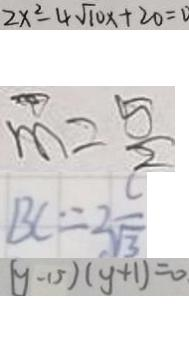Convert formula to latex. <formula><loc_0><loc_0><loc_500><loc_500>2 x ^ { 2 } - 4 \sqrt { 1 0 } x + 2 0 = 0 
 m = \frac { 5 } { 2 } 
 B C = 2 \frac { c } { \sqrt { 3 } } 
 ( y - 1 5 ) ( y + 1 ) = 0</formula> 